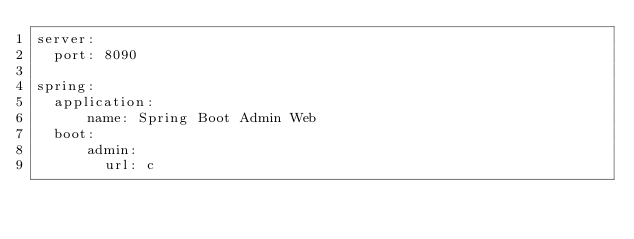Convert code to text. <code><loc_0><loc_0><loc_500><loc_500><_YAML_>server:
  port: 8090

spring:
  application:
      name: Spring Boot Admin Web
  boot:
      admin:
        url: c</code> 